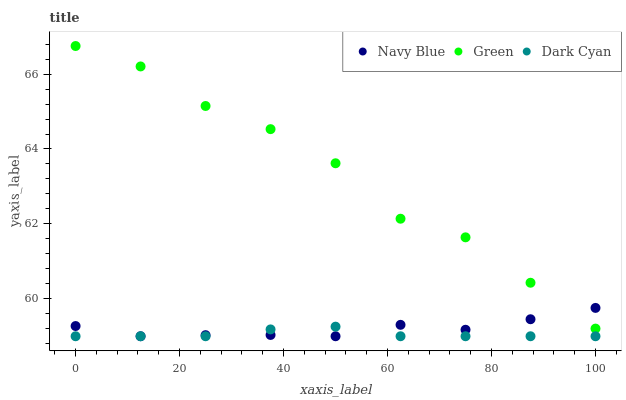Does Dark Cyan have the minimum area under the curve?
Answer yes or no. Yes. Does Green have the maximum area under the curve?
Answer yes or no. Yes. Does Navy Blue have the minimum area under the curve?
Answer yes or no. No. Does Navy Blue have the maximum area under the curve?
Answer yes or no. No. Is Dark Cyan the smoothest?
Answer yes or no. Yes. Is Green the roughest?
Answer yes or no. Yes. Is Navy Blue the smoothest?
Answer yes or no. No. Is Navy Blue the roughest?
Answer yes or no. No. Does Dark Cyan have the lowest value?
Answer yes or no. Yes. Does Green have the lowest value?
Answer yes or no. No. Does Green have the highest value?
Answer yes or no. Yes. Does Navy Blue have the highest value?
Answer yes or no. No. Is Dark Cyan less than Green?
Answer yes or no. Yes. Is Green greater than Dark Cyan?
Answer yes or no. Yes. Does Navy Blue intersect Green?
Answer yes or no. Yes. Is Navy Blue less than Green?
Answer yes or no. No. Is Navy Blue greater than Green?
Answer yes or no. No. Does Dark Cyan intersect Green?
Answer yes or no. No. 